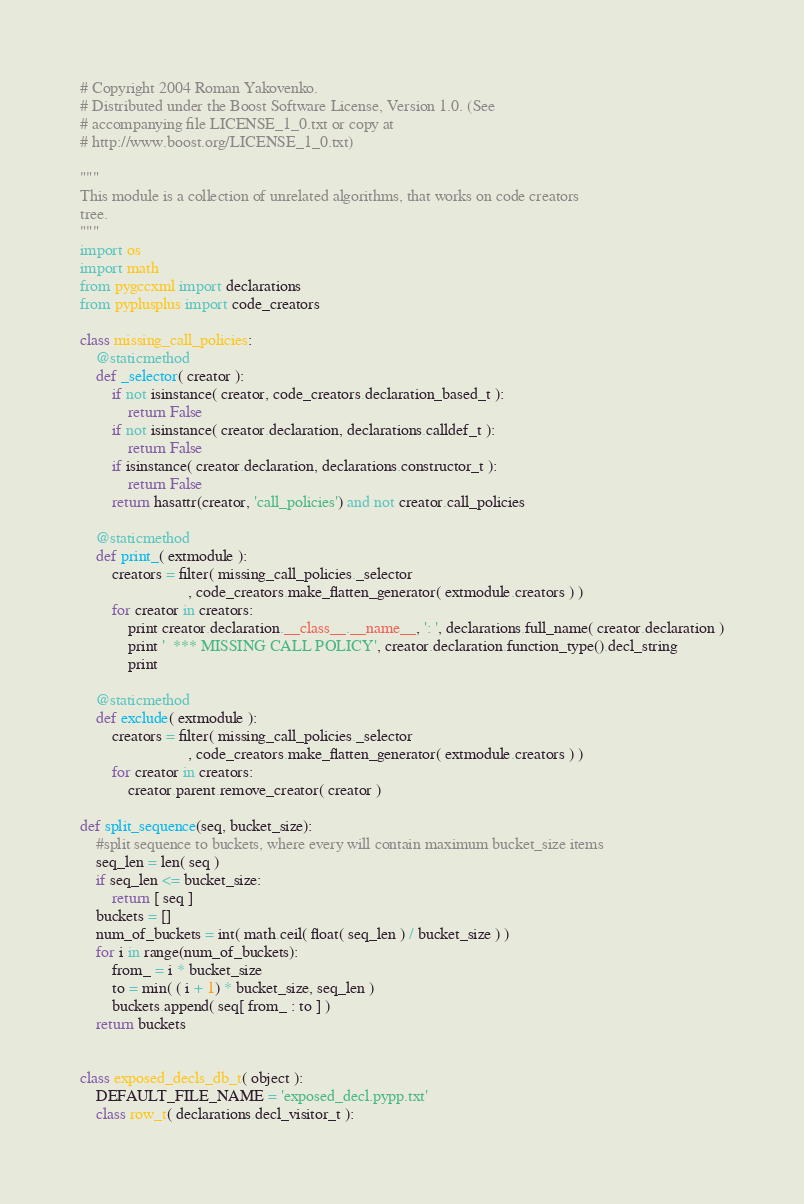<code> <loc_0><loc_0><loc_500><loc_500><_Python_># Copyright 2004 Roman Yakovenko.
# Distributed under the Boost Software License, Version 1.0. (See
# accompanying file LICENSE_1_0.txt or copy at
# http://www.boost.org/LICENSE_1_0.txt)

"""
This module is a collection of unrelated algorithms, that works on code creators
tree.
"""
import os
import math
from pygccxml import declarations
from pyplusplus import code_creators  

class missing_call_policies:
    @staticmethod
    def _selector( creator ):
        if not isinstance( creator, code_creators.declaration_based_t ):
            return False
        if not isinstance( creator.declaration, declarations.calldef_t ):
            return False
        if isinstance( creator.declaration, declarations.constructor_t ):
            return False
        return hasattr(creator, 'call_policies') and not creator.call_policies

    @staticmethod    
    def print_( extmodule ):
        creators = filter( missing_call_policies._selector
                           , code_creators.make_flatten_generator( extmodule.creators ) )
        for creator in creators:
            print creator.declaration.__class__.__name__, ': ', declarations.full_name( creator.declaration )
            print '  *** MISSING CALL POLICY', creator.declaration.function_type().decl_string
            print 

    @staticmethod    
    def exclude( extmodule ):
        creators = filter( missing_call_policies._selector
                           , code_creators.make_flatten_generator( extmodule.creators ) )
        for creator in creators:
            creator.parent.remove_creator( creator )
    
def split_sequence(seq, bucket_size):
    #split sequence to buckets, where every will contain maximum bucket_size items
    seq_len = len( seq )
    if seq_len <= bucket_size:
        return [ seq ] 
    buckets = []
    num_of_buckets = int( math.ceil( float( seq_len ) / bucket_size ) )
    for i in range(num_of_buckets):
        from_ = i * bucket_size
        to = min( ( i + 1) * bucket_size, seq_len )
        buckets.append( seq[ from_ : to ] )
    return buckets
    

class exposed_decls_db_t( object ):
    DEFAULT_FILE_NAME = 'exposed_decl.pypp.txt'
    class row_t( declarations.decl_visitor_t ):</code> 